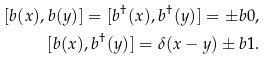<formula> <loc_0><loc_0><loc_500><loc_500>[ { b } ( x ) , { b } ( y ) ] = [ { b } ^ { \dag } ( x ) , { b } ^ { \dag } ( y ) ] = \pm b 0 , \\ [ { b } ( x ) , { b } ^ { \dag } ( y ) ] = \delta ( x - y ) \pm b 1 .</formula> 